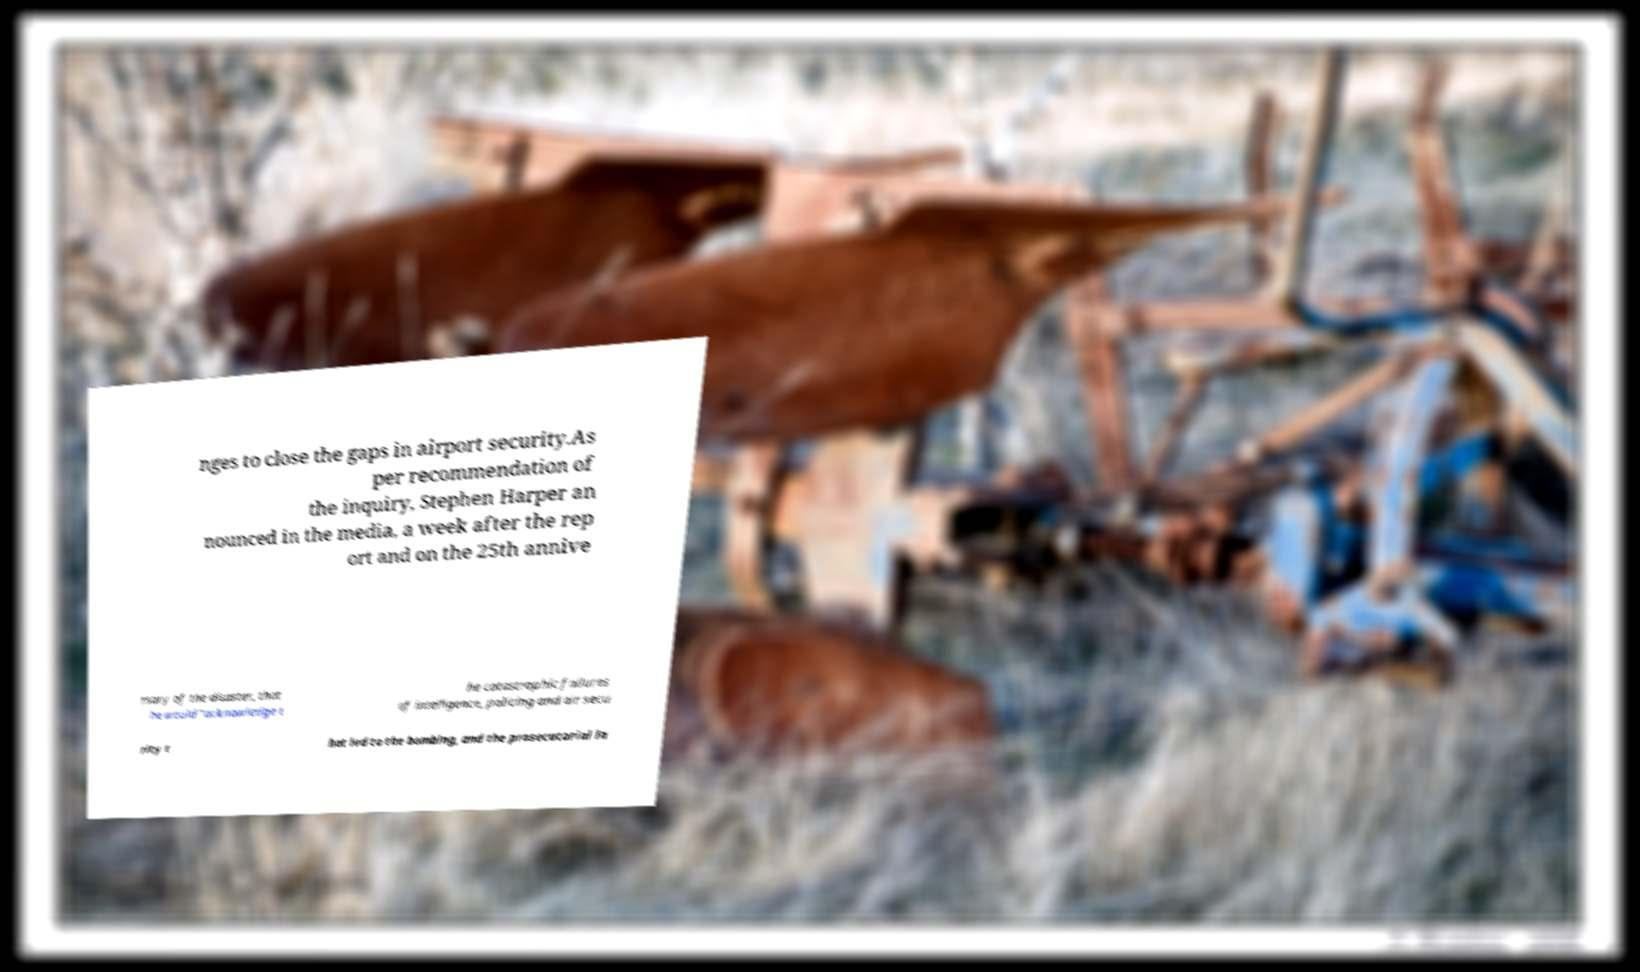Could you extract and type out the text from this image? nges to close the gaps in airport security.As per recommendation of the inquiry, Stephen Harper an nounced in the media, a week after the rep ort and on the 25th annive rsary of the disaster, that he would "acknowledge t he catastrophic failures of intelligence, policing and air secu rity t hat led to the bombing, and the prosecutorial la 